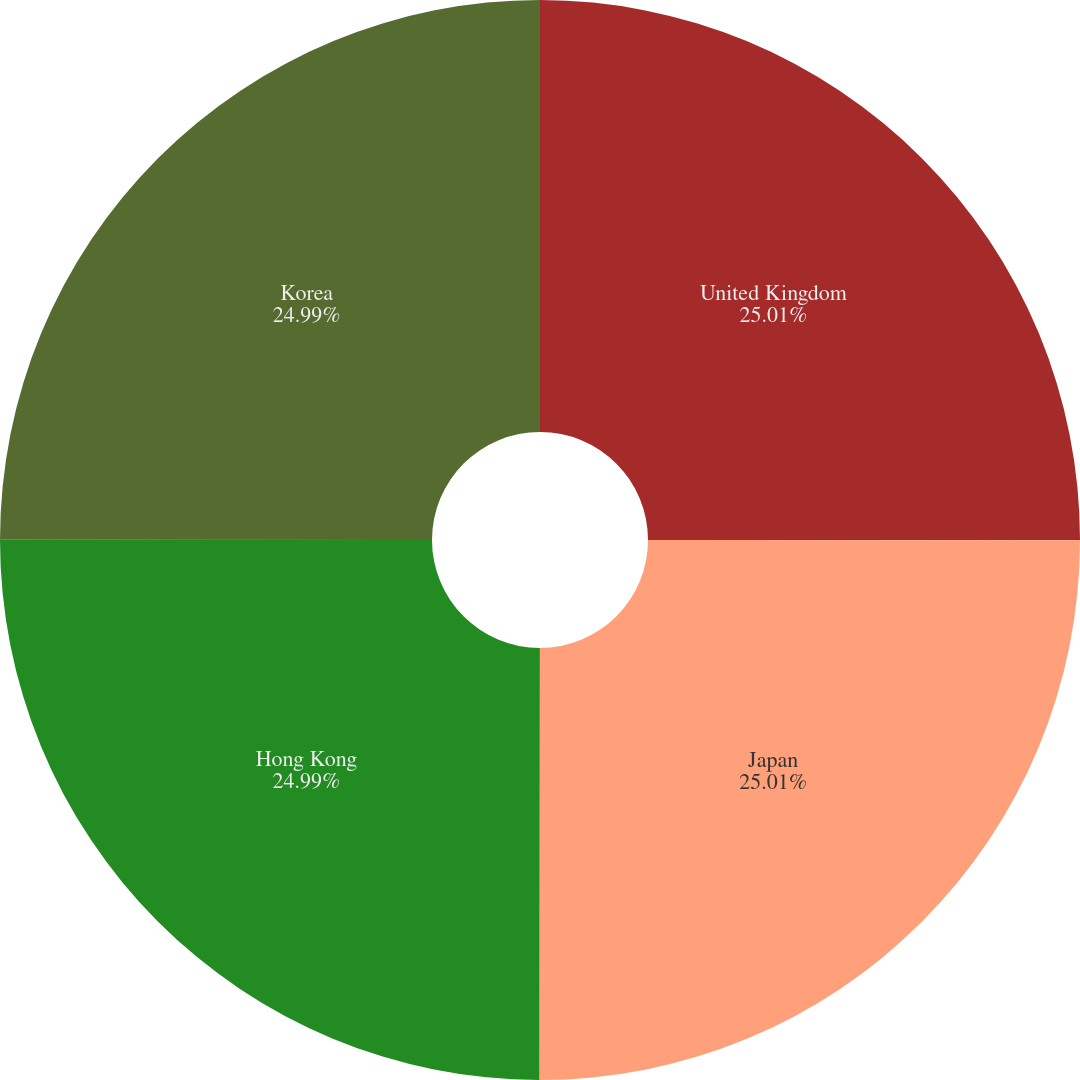<chart> <loc_0><loc_0><loc_500><loc_500><pie_chart><fcel>United Kingdom<fcel>Japan<fcel>Hong Kong<fcel>Korea<nl><fcel>25.01%<fcel>25.01%<fcel>24.99%<fcel>24.99%<nl></chart> 